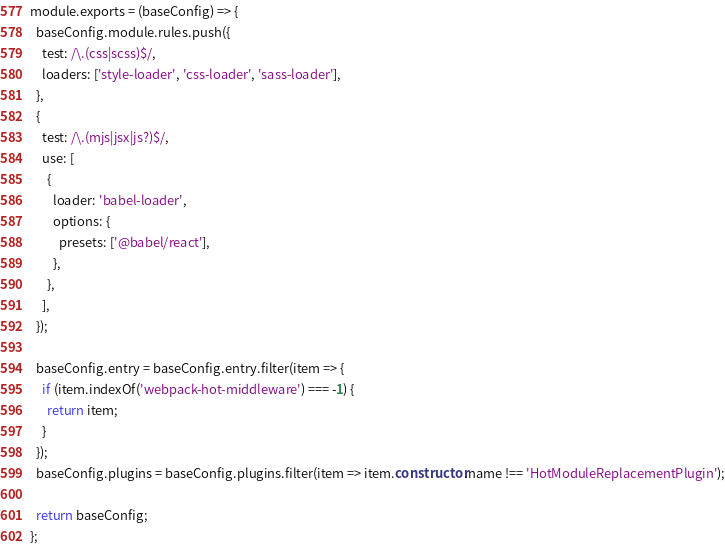Convert code to text. <code><loc_0><loc_0><loc_500><loc_500><_JavaScript_>module.exports = (baseConfig) => {
  baseConfig.module.rules.push({
    test: /\.(css|scss)$/,
    loaders: ['style-loader', 'css-loader', 'sass-loader'],
  },
  {
    test: /\.(mjs|jsx|js?)$/,
    use: [
      {
        loader: 'babel-loader',
        options: {
          presets: ['@babel/react'],
        },
      },
    ],
  });

  baseConfig.entry = baseConfig.entry.filter(item => {
    if (item.indexOf('webpack-hot-middleware') === -1) {
      return item;
    }
  });
  baseConfig.plugins = baseConfig.plugins.filter(item => item.constructor.name !== 'HotModuleReplacementPlugin');

  return baseConfig;
};
</code> 